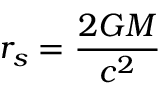<formula> <loc_0><loc_0><loc_500><loc_500>r _ { s } = \frac { 2 G M } { c ^ { 2 } }</formula> 